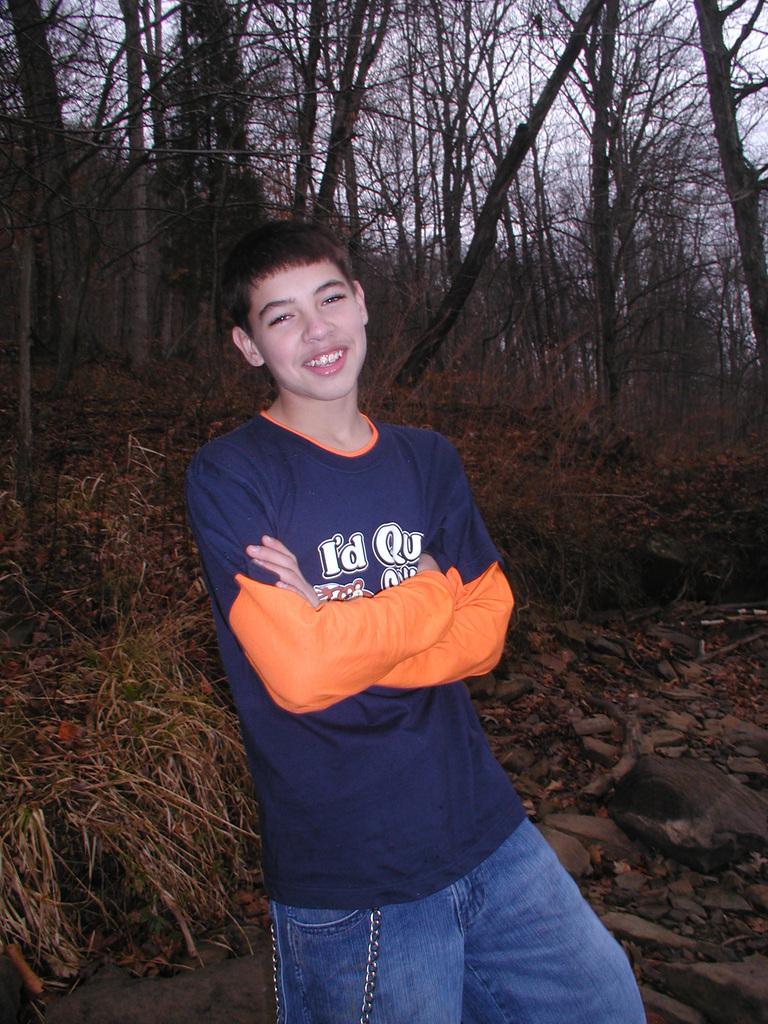What is the first word on the boys shirt?
Your answer should be very brief. I'd. What is the first letter of the second word on the boys shirt?
Give a very brief answer. Q. 